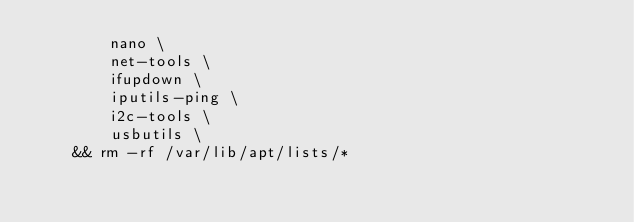Convert code to text. <code><loc_0><loc_0><loc_500><loc_500><_Dockerfile_>		nano \
		net-tools \
		ifupdown \
		iputils-ping \
		i2c-tools \
		usbutils \
	&& rm -rf /var/lib/apt/lists/*</code> 